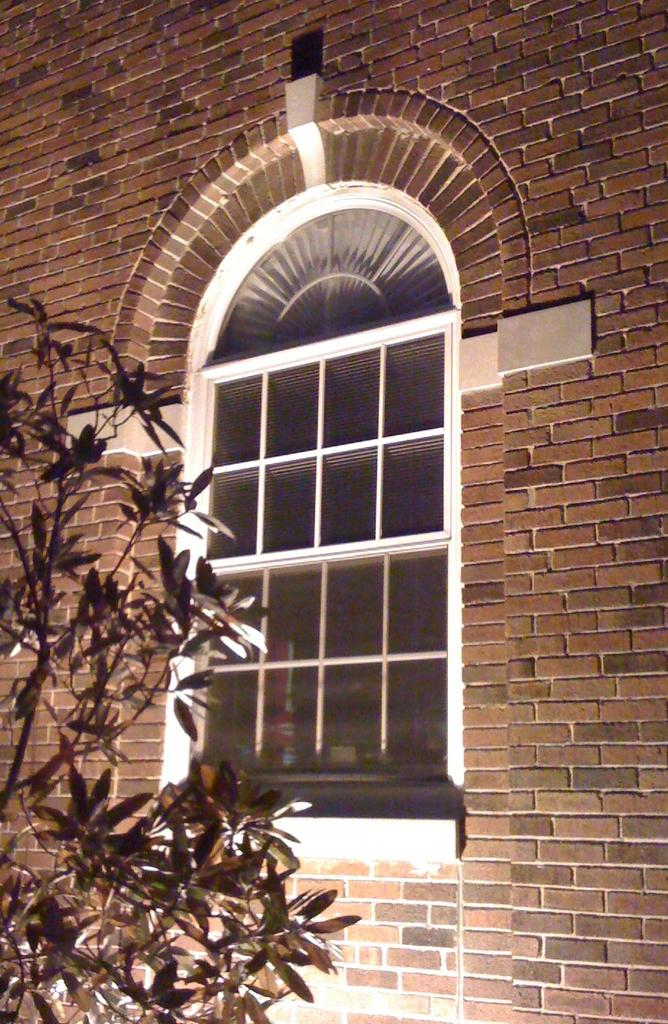What type of structure can be seen in the image? There is a brick wall in the image. What architectural feature is present in the brick wall? There is a window in the image. What type of vegetation is visible in the image? Leaves on stems are visible in the image. How many cherries are hanging from the mitten in the image? There is no mitten or cherries present in the image. 